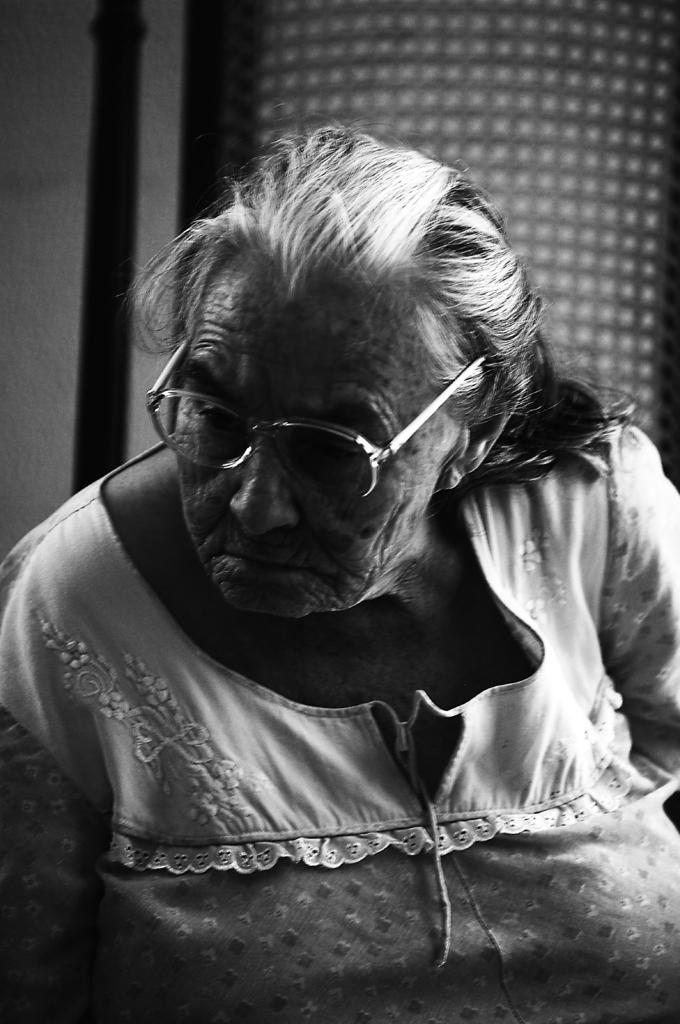What is the main subject of the image? The main subject of the image is a woman. Can you describe any specific features of the woman? Yes, the woman is wearing glasses (specs). What is the color scheme of the image? The image is black and white in color. What type of flower is growing in the woman's hair in the image? There is no flower present in the image, as it is a black and white photograph of a woman wearing glasses. 